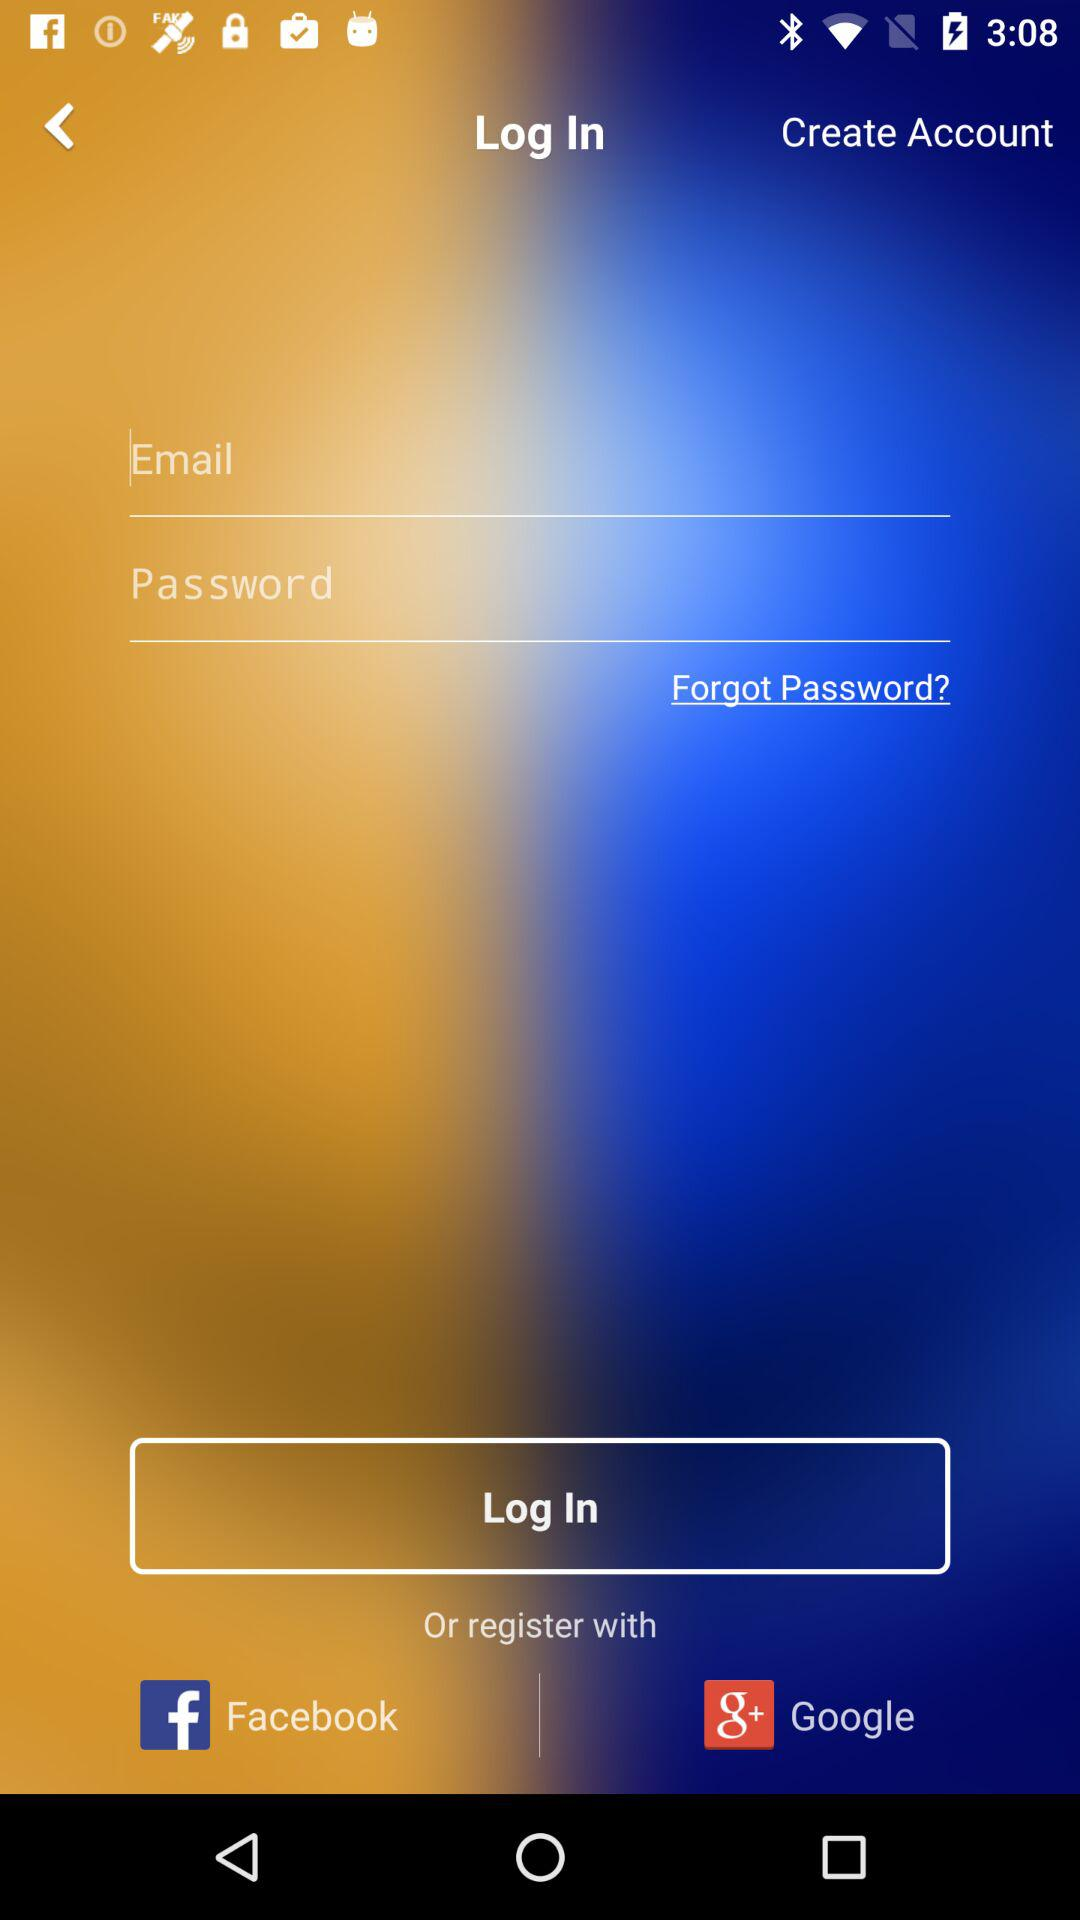What accounts are available for registration? The accounts are "Facebook" and "Google". 